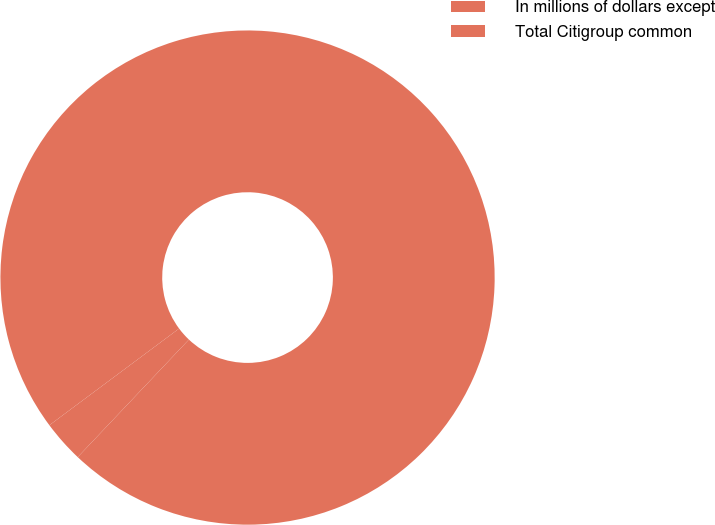<chart> <loc_0><loc_0><loc_500><loc_500><pie_chart><fcel>In millions of dollars except<fcel>Total Citigroup common<nl><fcel>2.75%<fcel>97.25%<nl></chart> 